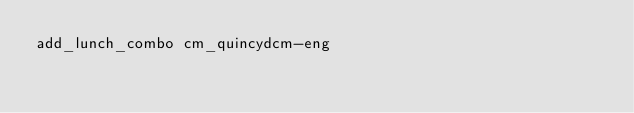<code> <loc_0><loc_0><loc_500><loc_500><_Bash_>add_lunch_combo cm_quincydcm-eng

</code> 